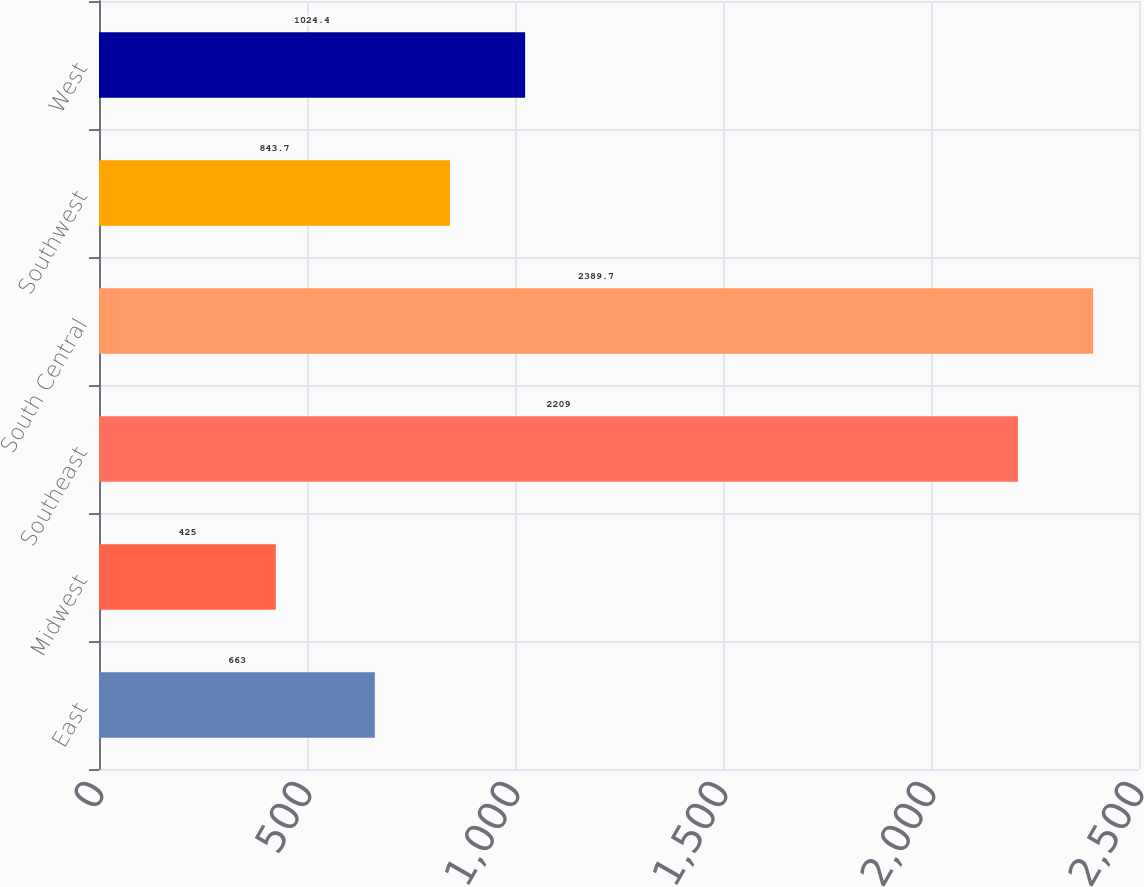<chart> <loc_0><loc_0><loc_500><loc_500><bar_chart><fcel>East<fcel>Midwest<fcel>Southeast<fcel>South Central<fcel>Southwest<fcel>West<nl><fcel>663<fcel>425<fcel>2209<fcel>2389.7<fcel>843.7<fcel>1024.4<nl></chart> 